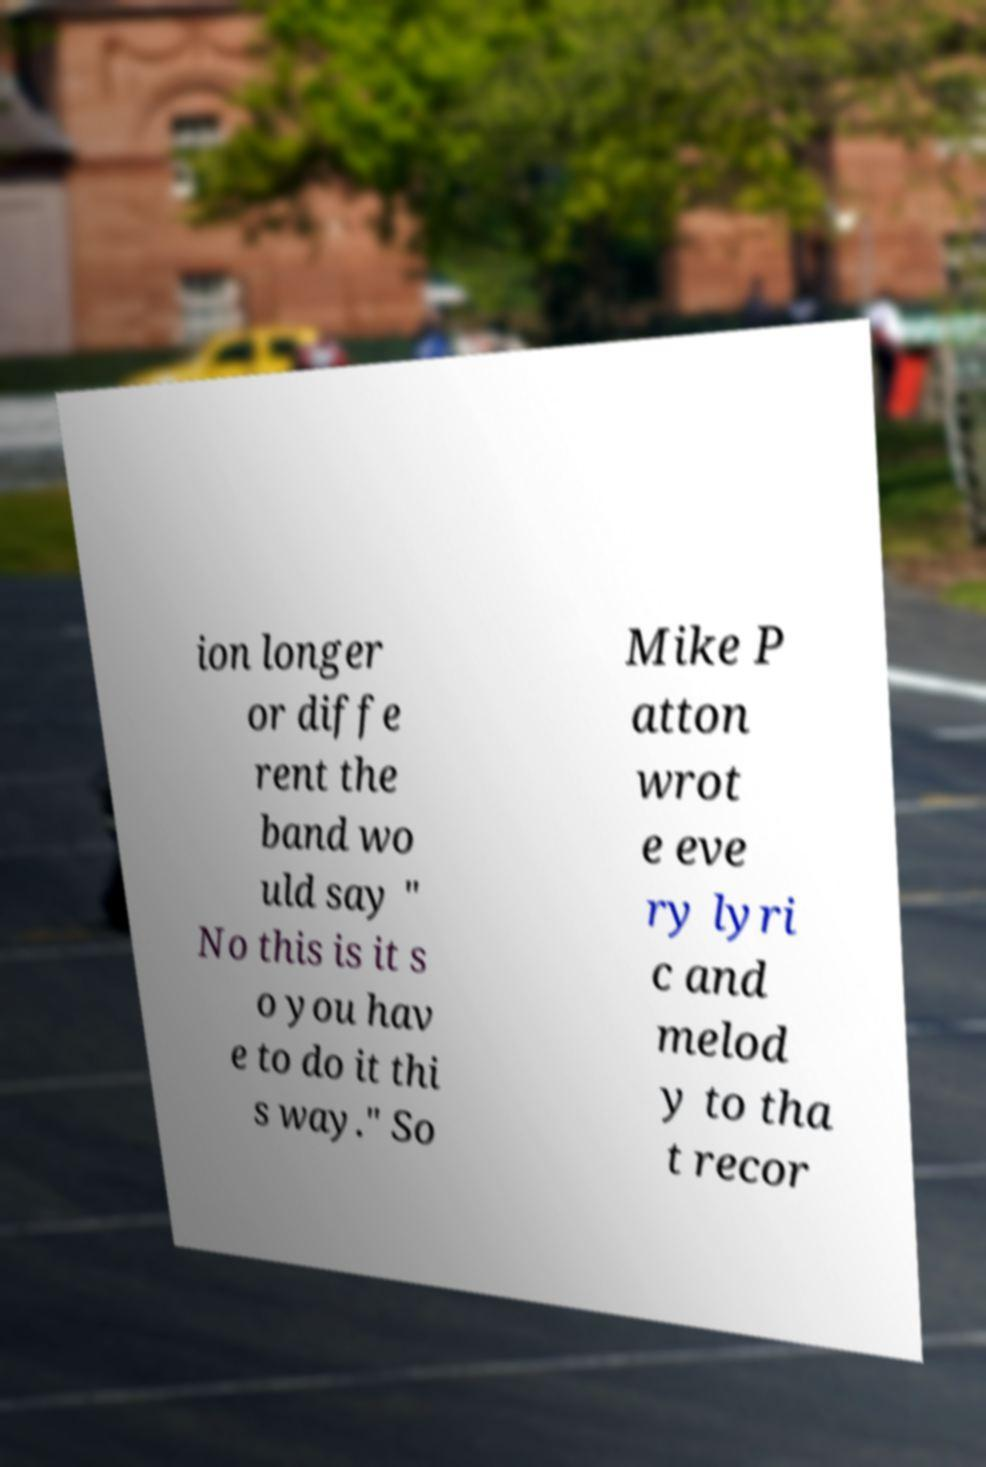Could you extract and type out the text from this image? ion longer or diffe rent the band wo uld say " No this is it s o you hav e to do it thi s way." So Mike P atton wrot e eve ry lyri c and melod y to tha t recor 